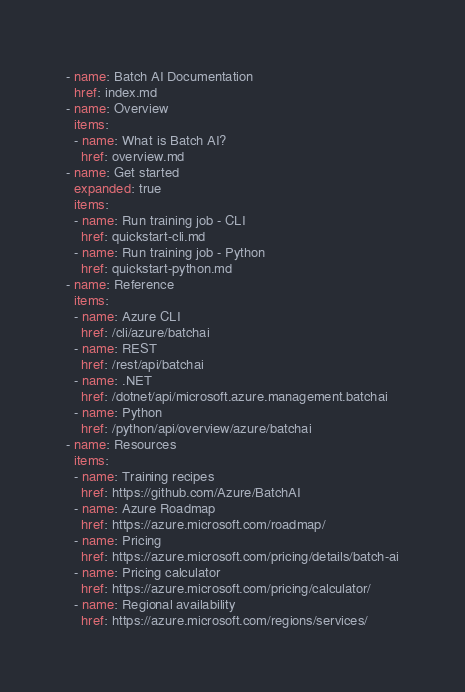<code> <loc_0><loc_0><loc_500><loc_500><_YAML_>- name: Batch AI Documentation
  href: index.md
- name: Overview
  items:
  - name: What is Batch AI?
    href: overview.md
- name: Get started
  expanded: true
  items:
  - name: Run training job - CLI
    href: quickstart-cli.md
  - name: Run training job - Python
    href: quickstart-python.md
- name: Reference
  items:
  - name: Azure CLI
    href: /cli/azure/batchai
  - name: REST
    href: /rest/api/batchai
  - name: .NET
    href: /dotnet/api/microsoft.azure.management.batchai
  - name: Python
    href: /python/api/overview/azure/batchai
- name: Resources
  items:
  - name: Training recipes
    href: https://github.com/Azure/BatchAI
  - name: Azure Roadmap
    href: https://azure.microsoft.com/roadmap/
  - name: Pricing
    href: https://azure.microsoft.com/pricing/details/batch-ai
  - name: Pricing calculator
    href: https://azure.microsoft.com/pricing/calculator/
  - name: Regional availability
    href: https://azure.microsoft.com/regions/services/</code> 